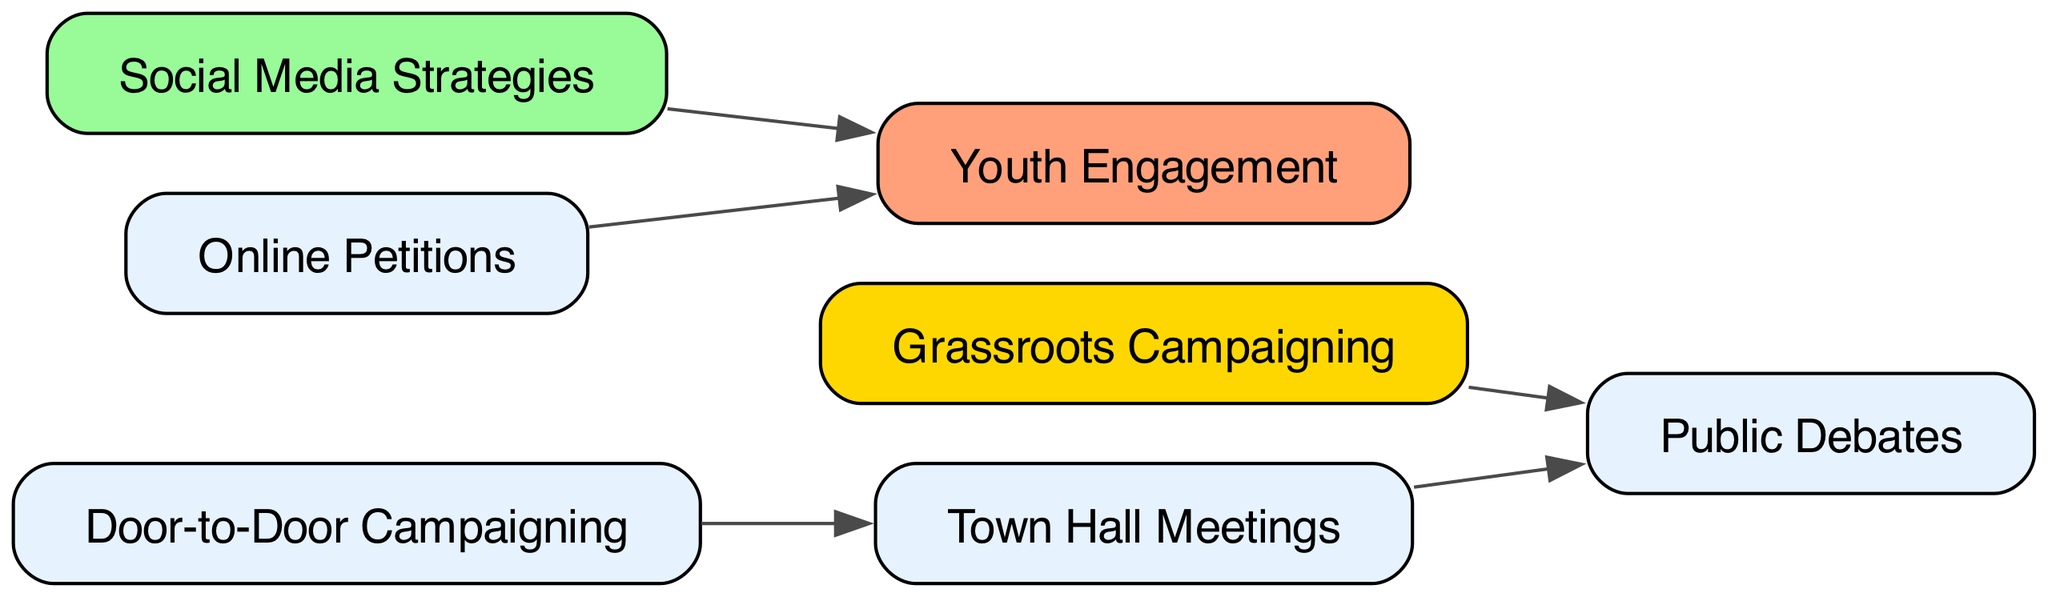What are the total number of nodes in the diagram? The diagram features a list of unique voter engagement strategies represented as nodes. Counting the nodes listed, we find that there are a total of 7 nodes: Grassroots Campaigning, Social Media Strategies, Door-to-Door Campaigning, Public Debates, Town Hall Meetings, Youth Engagement, and Online Petitions.
Answer: 7 Which strategy directly leads to Public Debates? The directed graph shows that Grassroots Campaigning and Town Hall Meetings have edges leading to Public Debates. To determine the answer, we specifically look for nodes that direct connect to Public Debates. Both strategies can be noted; however, the main focus would be one direct path. The direct flows are Grassroots Campaigning to Public Debates.
Answer: Grassroots Campaigning How many edges are present in the diagram? The edges represent the relationships between the various voter engagement strategies. By examining the listing of edges, we can see they connect the nodes: Grassroots Campaigning to Public Debates, Social Media Strategies to Youth Engagement, Door-to-Door Campaigning to Town Hall Meetings, Town Hall Meetings to Public Debates, and Online Petitions to Youth Engagement. Counting these reveals a total of 5 edges.
Answer: 5 Which strategies connect to Youth Engagement? The directed graph indicates that both Social Media Strategies and Online Petitions have edges that connect to Youth Engagement. To ascertain the answer, we trace the edges leading into Youth Engagement from the respective nodes, confirming these connections.
Answer: Social Media Strategies, Online Petitions What is the relationship between Door-to-Door Campaigning and Town Hall Meetings? The directed graph shows a direct edge from Door-to-Door Campaigning to Town Hall Meetings. Thus, the relationship can be described as a direct link where Door-to-Door Campaigning leads to Town Hall Meetings in the engagement strategies.
Answer: Direct connection Which two nodes lead to the same destination in the graph? Analyzing the edges in the graph tells us that both Grassroots Campaigning and Town Hall Meetings lead to the same destination of Public Debates. This indicates a common endpoint from different starting points.
Answer: Grassroots Campaigning, Town Hall Meetings How does the flow begin in the diagram? The flow in the diagram starts with various engagement strategies illustrated by the nodes. Notably, Grassroots Campaigning can be seen as a beginning strategy that connects to subsequent engagement activities. Following from this node shows a progression leading to other strategies, particularly Public Debates. Therefore, Grassroots Campaigning is the starting point in the directed flow.
Answer: Grassroots Campaigning Which strategy is colored differently from the others in the diagram? Among the nodes depicted in the diagram, Grassroots Campaigning is highlighted with a different color, specifically gold, compared to the others which are a lighter hue. This distinctive coloring indicates a potential emphasis within the visual representation.
Answer: Grassroots Campaigning 